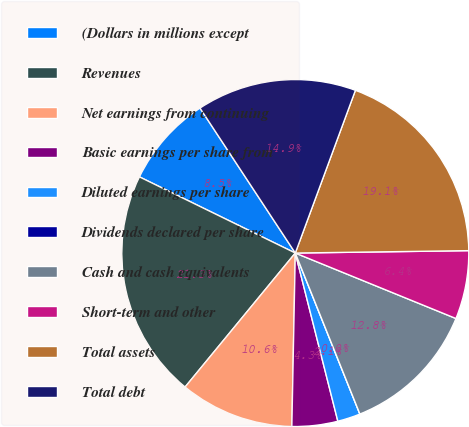<chart> <loc_0><loc_0><loc_500><loc_500><pie_chart><fcel>(Dollars in millions except<fcel>Revenues<fcel>Net earnings from continuing<fcel>Basic earnings per share from<fcel>Diluted earnings per share<fcel>Dividends declared per share<fcel>Cash and cash equivalents<fcel>Short-term and other<fcel>Total assets<fcel>Total debt<nl><fcel>8.51%<fcel>21.28%<fcel>10.64%<fcel>4.26%<fcel>2.13%<fcel>0.0%<fcel>12.77%<fcel>6.38%<fcel>19.15%<fcel>14.89%<nl></chart> 